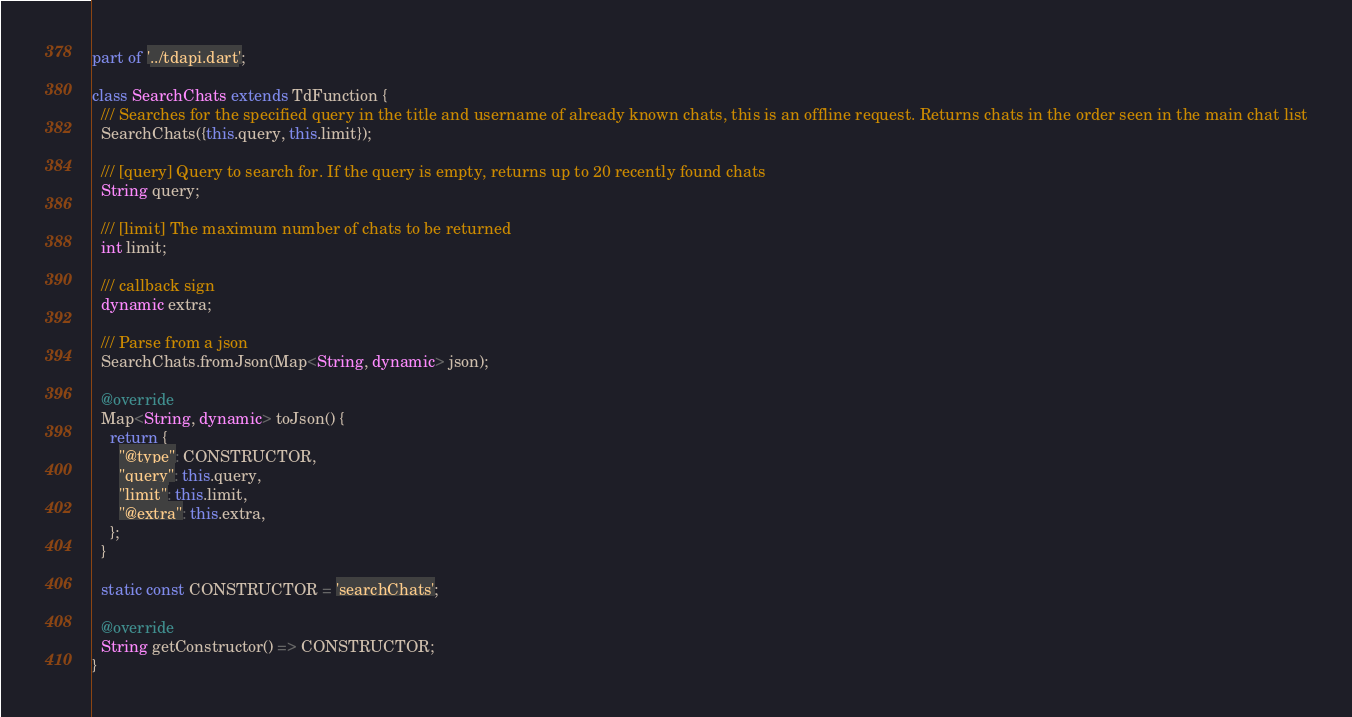Convert code to text. <code><loc_0><loc_0><loc_500><loc_500><_Dart_>part of '../tdapi.dart';

class SearchChats extends TdFunction {
  /// Searches for the specified query in the title and username of already known chats, this is an offline request. Returns chats in the order seen in the main chat list
  SearchChats({this.query, this.limit});

  /// [query] Query to search for. If the query is empty, returns up to 20 recently found chats
  String query;

  /// [limit] The maximum number of chats to be returned
  int limit;

  /// callback sign
  dynamic extra;

  /// Parse from a json
  SearchChats.fromJson(Map<String, dynamic> json);

  @override
  Map<String, dynamic> toJson() {
    return {
      "@type": CONSTRUCTOR,
      "query": this.query,
      "limit": this.limit,
      "@extra": this.extra,
    };
  }

  static const CONSTRUCTOR = 'searchChats';

  @override
  String getConstructor() => CONSTRUCTOR;
}
</code> 